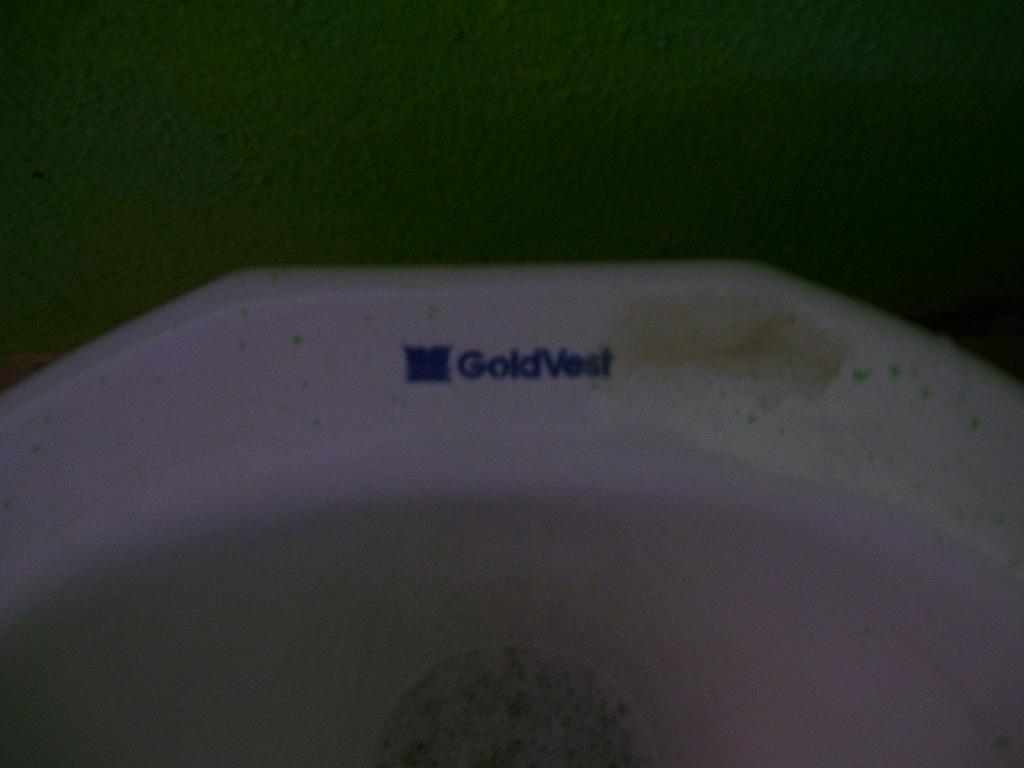What is the color of the white object in the image? The white object in the image has "gold vest" written on it. What is written on the white object in the image? The white object has "gold vest" written on it. What is the color of the wall in the image? The wall in the image is green in color. How many years has the white object been stretching in the image? The white object is not stretching in the image, and there is no indication of time or duration. What is the temper of the person wearing the "gold vest" in the image? There is no information about the temper of the person wearing the "gold vest" in the image. 